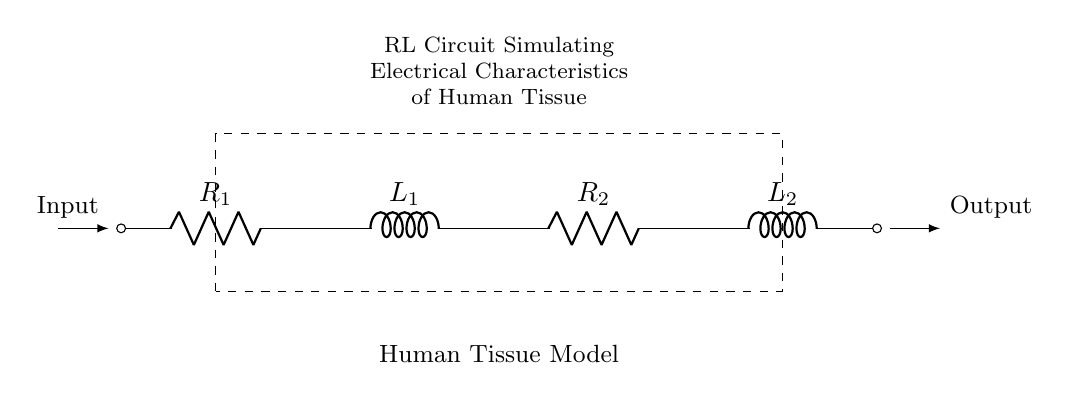What are the components in this circuit? The components visible in the circuit diagram include two resistors labeled R1 and R2, and two inductors labeled L1 and L2.
Answer: R1, R2, L1, L2 What type of circuit is shown in the diagram? The circuit is described as an RL circuit, which includes resistors and inductors. This indicates it is specifically designed to analyze resistive and inductive properties.
Answer: RL circuit How many inductors are present in this circuit? The diagram shows two inductors, L1 and L2, which are explicitly labeled in the circuit representation.
Answer: 2 What does the dashed rectangle represent? The dashed rectangle surrounding the components indicates a model for human tissue, hence denoting that the electrical characteristics of human tissue are being simulated within this boundary.
Answer: Human Tissue Model What is the function of the input connection in this circuit? The input connection at the left side of the circuit delivers electrical energy into the circuit, which is necessary for creating the simulation of human tissue.
Answer: Input What can you infer about the relationship between resistance and inductance in this circuit? In an RL circuit, the resistance and inductance affect the phase angle and impedance; resistance R1 and R2 will dissipate energy while L1 and L2 will store energy in a magnetic field, determining the overall behavior when energized.
Answer: Resistive and Inductive relationship What is the output connection used for in this circuit? The output connection at the right side of the circuit represents where the response from the simulated human tissue model can be measured or utilized for further analysis.
Answer: Output 